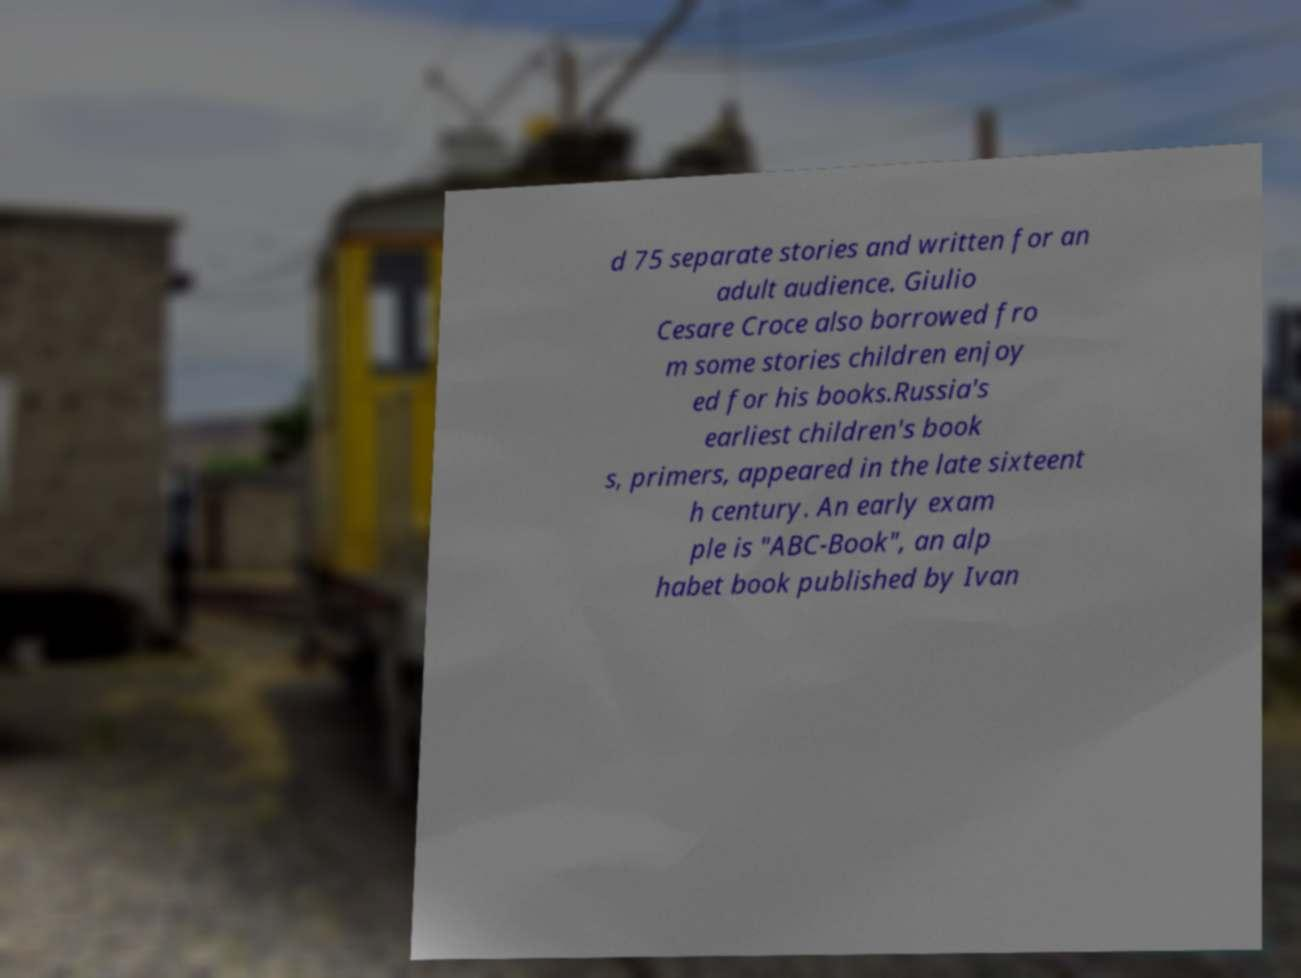Please identify and transcribe the text found in this image. d 75 separate stories and written for an adult audience. Giulio Cesare Croce also borrowed fro m some stories children enjoy ed for his books.Russia's earliest children's book s, primers, appeared in the late sixteent h century. An early exam ple is "ABC-Book", an alp habet book published by Ivan 